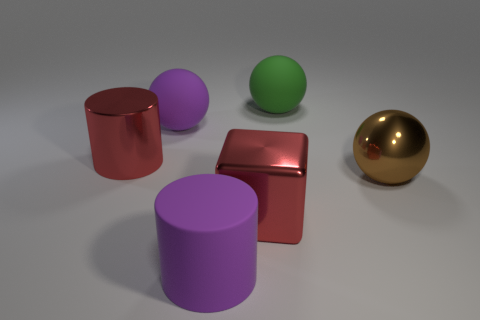Do the metallic cylinder and the big matte cylinder have the same color? No, they do not. The metallic cylinder has a reflective gold finish, whereas the big matte cylinder exhibits a solid purple color with no reflective properties. 